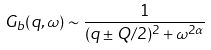Convert formula to latex. <formula><loc_0><loc_0><loc_500><loc_500>G _ { b } ( { q } , \omega ) \sim \frac { 1 } { ( { q } \pm { Q } / 2 ) ^ { 2 } + \omega ^ { 2 \alpha } }</formula> 